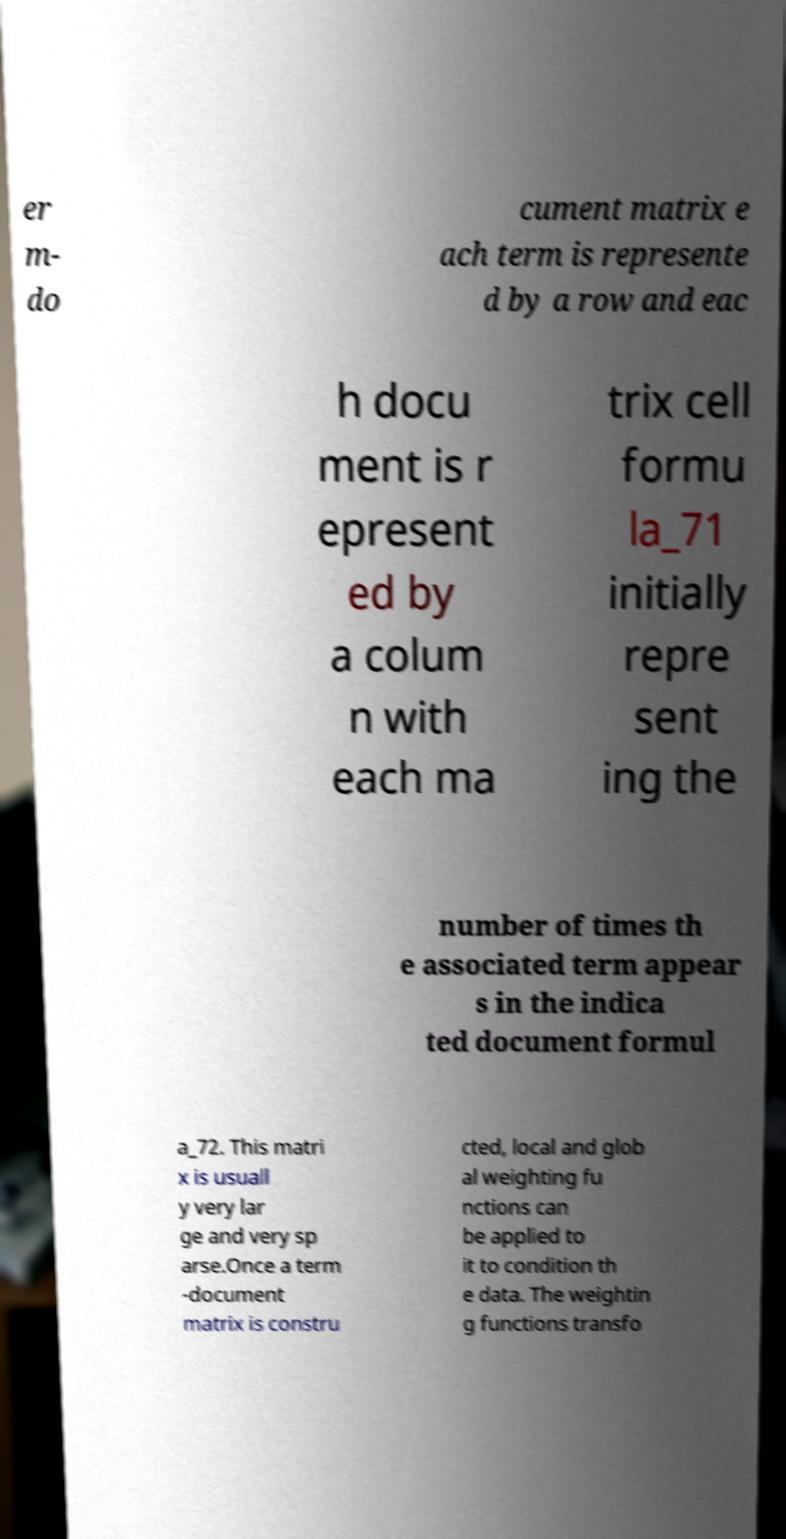I need the written content from this picture converted into text. Can you do that? er m- do cument matrix e ach term is represente d by a row and eac h docu ment is r epresent ed by a colum n with each ma trix cell formu la_71 initially repre sent ing the number of times th e associated term appear s in the indica ted document formul a_72. This matri x is usuall y very lar ge and very sp arse.Once a term -document matrix is constru cted, local and glob al weighting fu nctions can be applied to it to condition th e data. The weightin g functions transfo 